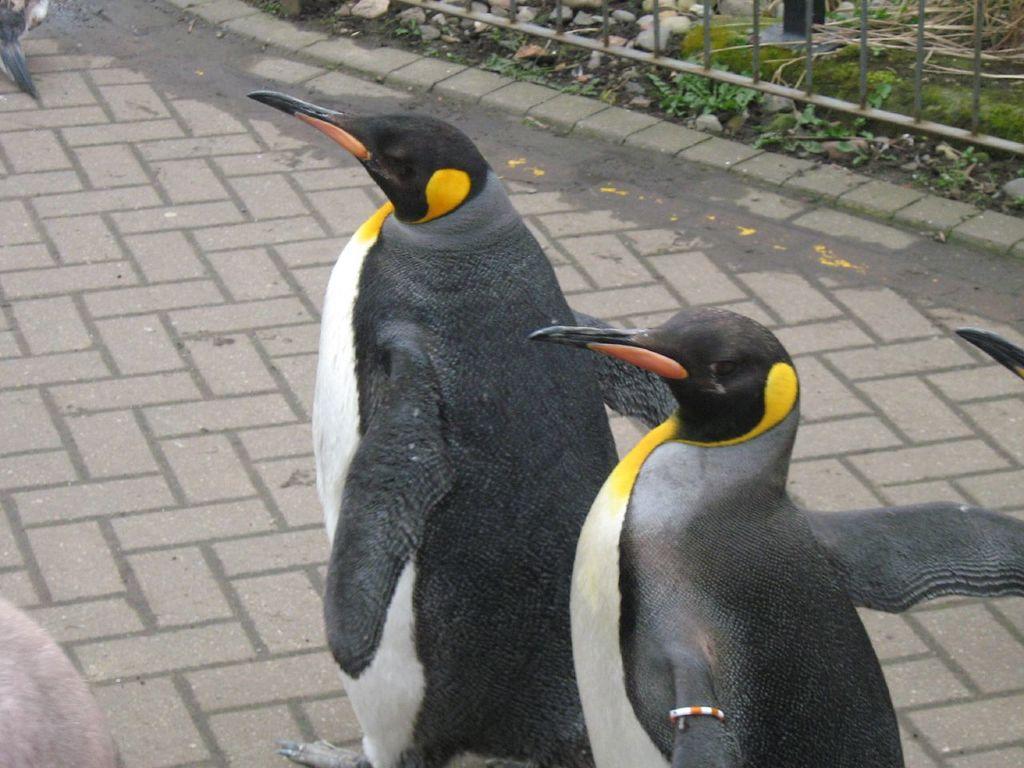Could you give a brief overview of what you see in this image? In this picture we can see there are some penguins on the walkway. On the right side of the penguins there are plants, stones and the iron grilles. 